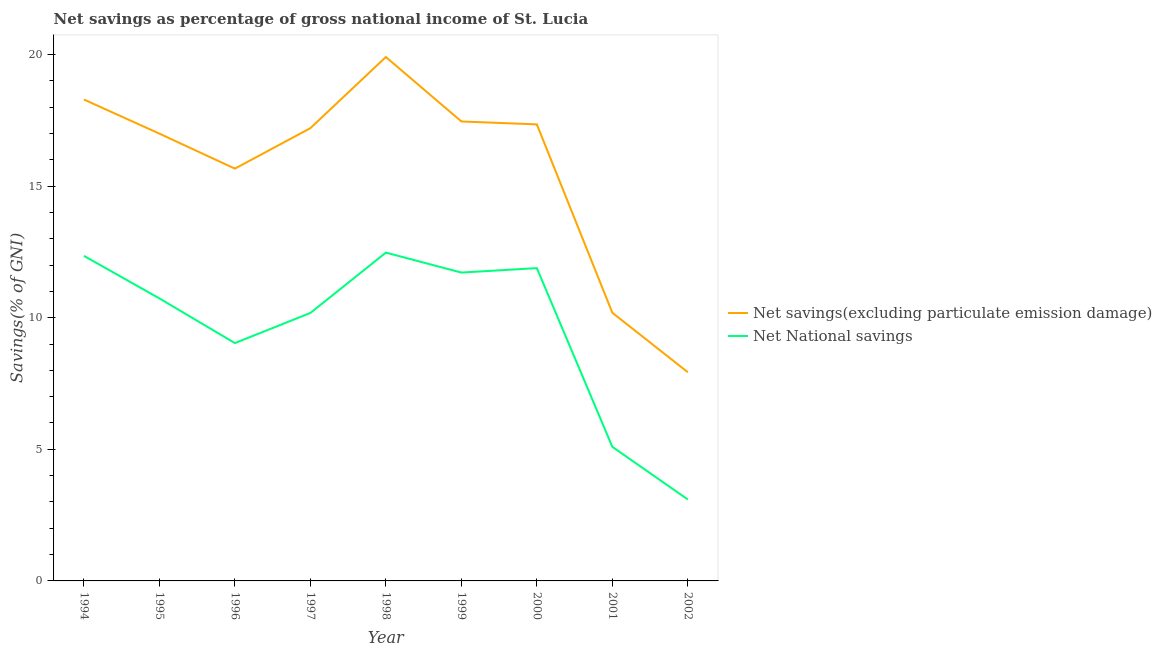Does the line corresponding to net savings(excluding particulate emission damage) intersect with the line corresponding to net national savings?
Your response must be concise. No. What is the net savings(excluding particulate emission damage) in 1994?
Give a very brief answer. 18.29. Across all years, what is the maximum net savings(excluding particulate emission damage)?
Offer a very short reply. 19.9. Across all years, what is the minimum net national savings?
Make the answer very short. 3.09. What is the total net savings(excluding particulate emission damage) in the graph?
Provide a succinct answer. 140.97. What is the difference between the net savings(excluding particulate emission damage) in 1997 and that in 2000?
Give a very brief answer. -0.14. What is the difference between the net savings(excluding particulate emission damage) in 1996 and the net national savings in 1994?
Your response must be concise. 3.31. What is the average net national savings per year?
Ensure brevity in your answer.  9.62. In the year 1997, what is the difference between the net savings(excluding particulate emission damage) and net national savings?
Give a very brief answer. 7.02. In how many years, is the net national savings greater than 19 %?
Give a very brief answer. 0. What is the ratio of the net savings(excluding particulate emission damage) in 1994 to that in 1995?
Offer a terse response. 1.08. What is the difference between the highest and the second highest net national savings?
Offer a terse response. 0.12. What is the difference between the highest and the lowest net savings(excluding particulate emission damage)?
Provide a short and direct response. 11.98. In how many years, is the net national savings greater than the average net national savings taken over all years?
Your answer should be compact. 6. Is the net national savings strictly greater than the net savings(excluding particulate emission damage) over the years?
Your answer should be compact. No. Is the net savings(excluding particulate emission damage) strictly less than the net national savings over the years?
Make the answer very short. No. How many lines are there?
Provide a succinct answer. 2. How many years are there in the graph?
Provide a succinct answer. 9. What is the difference between two consecutive major ticks on the Y-axis?
Offer a terse response. 5. Does the graph contain any zero values?
Your answer should be compact. No. Does the graph contain grids?
Keep it short and to the point. No. What is the title of the graph?
Give a very brief answer. Net savings as percentage of gross national income of St. Lucia. Does "Male" appear as one of the legend labels in the graph?
Keep it short and to the point. No. What is the label or title of the Y-axis?
Ensure brevity in your answer.  Savings(% of GNI). What is the Savings(% of GNI) of Net savings(excluding particulate emission damage) in 1994?
Your response must be concise. 18.29. What is the Savings(% of GNI) of Net National savings in 1994?
Your answer should be compact. 12.35. What is the Savings(% of GNI) of Net savings(excluding particulate emission damage) in 1995?
Keep it short and to the point. 16.99. What is the Savings(% of GNI) of Net National savings in 1995?
Provide a short and direct response. 10.73. What is the Savings(% of GNI) in Net savings(excluding particulate emission damage) in 1996?
Offer a terse response. 15.66. What is the Savings(% of GNI) of Net National savings in 1996?
Give a very brief answer. 9.04. What is the Savings(% of GNI) of Net savings(excluding particulate emission damage) in 1997?
Your response must be concise. 17.2. What is the Savings(% of GNI) in Net National savings in 1997?
Offer a terse response. 10.18. What is the Savings(% of GNI) of Net savings(excluding particulate emission damage) in 1998?
Make the answer very short. 19.9. What is the Savings(% of GNI) of Net National savings in 1998?
Keep it short and to the point. 12.47. What is the Savings(% of GNI) of Net savings(excluding particulate emission damage) in 1999?
Ensure brevity in your answer.  17.46. What is the Savings(% of GNI) in Net National savings in 1999?
Your answer should be very brief. 11.71. What is the Savings(% of GNI) of Net savings(excluding particulate emission damage) in 2000?
Keep it short and to the point. 17.34. What is the Savings(% of GNI) of Net National savings in 2000?
Your answer should be compact. 11.88. What is the Savings(% of GNI) of Net savings(excluding particulate emission damage) in 2001?
Make the answer very short. 10.19. What is the Savings(% of GNI) in Net National savings in 2001?
Your response must be concise. 5.09. What is the Savings(% of GNI) of Net savings(excluding particulate emission damage) in 2002?
Provide a succinct answer. 7.93. What is the Savings(% of GNI) in Net National savings in 2002?
Your answer should be very brief. 3.09. Across all years, what is the maximum Savings(% of GNI) in Net savings(excluding particulate emission damage)?
Your answer should be compact. 19.9. Across all years, what is the maximum Savings(% of GNI) of Net National savings?
Make the answer very short. 12.47. Across all years, what is the minimum Savings(% of GNI) in Net savings(excluding particulate emission damage)?
Keep it short and to the point. 7.93. Across all years, what is the minimum Savings(% of GNI) of Net National savings?
Your answer should be very brief. 3.09. What is the total Savings(% of GNI) in Net savings(excluding particulate emission damage) in the graph?
Give a very brief answer. 140.97. What is the total Savings(% of GNI) in Net National savings in the graph?
Make the answer very short. 86.56. What is the difference between the Savings(% of GNI) in Net savings(excluding particulate emission damage) in 1994 and that in 1995?
Give a very brief answer. 1.3. What is the difference between the Savings(% of GNI) of Net National savings in 1994 and that in 1995?
Your answer should be very brief. 1.62. What is the difference between the Savings(% of GNI) of Net savings(excluding particulate emission damage) in 1994 and that in 1996?
Offer a terse response. 2.63. What is the difference between the Savings(% of GNI) of Net National savings in 1994 and that in 1996?
Offer a terse response. 3.31. What is the difference between the Savings(% of GNI) of Net savings(excluding particulate emission damage) in 1994 and that in 1997?
Provide a short and direct response. 1.09. What is the difference between the Savings(% of GNI) of Net National savings in 1994 and that in 1997?
Give a very brief answer. 2.17. What is the difference between the Savings(% of GNI) in Net savings(excluding particulate emission damage) in 1994 and that in 1998?
Your answer should be compact. -1.62. What is the difference between the Savings(% of GNI) of Net National savings in 1994 and that in 1998?
Make the answer very short. -0.12. What is the difference between the Savings(% of GNI) of Net savings(excluding particulate emission damage) in 1994 and that in 1999?
Your response must be concise. 0.83. What is the difference between the Savings(% of GNI) of Net National savings in 1994 and that in 1999?
Keep it short and to the point. 0.63. What is the difference between the Savings(% of GNI) in Net savings(excluding particulate emission damage) in 1994 and that in 2000?
Your response must be concise. 0.94. What is the difference between the Savings(% of GNI) of Net National savings in 1994 and that in 2000?
Offer a terse response. 0.47. What is the difference between the Savings(% of GNI) of Net savings(excluding particulate emission damage) in 1994 and that in 2001?
Your answer should be compact. 8.1. What is the difference between the Savings(% of GNI) in Net National savings in 1994 and that in 2001?
Offer a terse response. 7.26. What is the difference between the Savings(% of GNI) in Net savings(excluding particulate emission damage) in 1994 and that in 2002?
Your answer should be very brief. 10.36. What is the difference between the Savings(% of GNI) of Net National savings in 1994 and that in 2002?
Offer a terse response. 9.26. What is the difference between the Savings(% of GNI) in Net savings(excluding particulate emission damage) in 1995 and that in 1996?
Keep it short and to the point. 1.33. What is the difference between the Savings(% of GNI) in Net National savings in 1995 and that in 1996?
Keep it short and to the point. 1.7. What is the difference between the Savings(% of GNI) of Net savings(excluding particulate emission damage) in 1995 and that in 1997?
Your answer should be compact. -0.21. What is the difference between the Savings(% of GNI) in Net National savings in 1995 and that in 1997?
Your answer should be compact. 0.55. What is the difference between the Savings(% of GNI) of Net savings(excluding particulate emission damage) in 1995 and that in 1998?
Give a very brief answer. -2.91. What is the difference between the Savings(% of GNI) of Net National savings in 1995 and that in 1998?
Keep it short and to the point. -1.74. What is the difference between the Savings(% of GNI) of Net savings(excluding particulate emission damage) in 1995 and that in 1999?
Make the answer very short. -0.46. What is the difference between the Savings(% of GNI) of Net National savings in 1995 and that in 1999?
Offer a very short reply. -0.98. What is the difference between the Savings(% of GNI) in Net savings(excluding particulate emission damage) in 1995 and that in 2000?
Offer a terse response. -0.35. What is the difference between the Savings(% of GNI) in Net National savings in 1995 and that in 2000?
Ensure brevity in your answer.  -1.15. What is the difference between the Savings(% of GNI) in Net savings(excluding particulate emission damage) in 1995 and that in 2001?
Your answer should be very brief. 6.8. What is the difference between the Savings(% of GNI) in Net National savings in 1995 and that in 2001?
Ensure brevity in your answer.  5.64. What is the difference between the Savings(% of GNI) in Net savings(excluding particulate emission damage) in 1995 and that in 2002?
Provide a succinct answer. 9.07. What is the difference between the Savings(% of GNI) of Net National savings in 1995 and that in 2002?
Give a very brief answer. 7.64. What is the difference between the Savings(% of GNI) in Net savings(excluding particulate emission damage) in 1996 and that in 1997?
Ensure brevity in your answer.  -1.54. What is the difference between the Savings(% of GNI) of Net National savings in 1996 and that in 1997?
Your answer should be compact. -1.14. What is the difference between the Savings(% of GNI) of Net savings(excluding particulate emission damage) in 1996 and that in 1998?
Make the answer very short. -4.24. What is the difference between the Savings(% of GNI) in Net National savings in 1996 and that in 1998?
Your answer should be very brief. -3.44. What is the difference between the Savings(% of GNI) of Net savings(excluding particulate emission damage) in 1996 and that in 1999?
Offer a terse response. -1.79. What is the difference between the Savings(% of GNI) of Net National savings in 1996 and that in 1999?
Provide a succinct answer. -2.68. What is the difference between the Savings(% of GNI) of Net savings(excluding particulate emission damage) in 1996 and that in 2000?
Offer a very short reply. -1.68. What is the difference between the Savings(% of GNI) of Net National savings in 1996 and that in 2000?
Offer a very short reply. -2.85. What is the difference between the Savings(% of GNI) in Net savings(excluding particulate emission damage) in 1996 and that in 2001?
Provide a short and direct response. 5.48. What is the difference between the Savings(% of GNI) of Net National savings in 1996 and that in 2001?
Make the answer very short. 3.94. What is the difference between the Savings(% of GNI) in Net savings(excluding particulate emission damage) in 1996 and that in 2002?
Make the answer very short. 7.74. What is the difference between the Savings(% of GNI) in Net National savings in 1996 and that in 2002?
Offer a terse response. 5.94. What is the difference between the Savings(% of GNI) of Net savings(excluding particulate emission damage) in 1997 and that in 1998?
Provide a short and direct response. -2.7. What is the difference between the Savings(% of GNI) of Net National savings in 1997 and that in 1998?
Provide a succinct answer. -2.29. What is the difference between the Savings(% of GNI) in Net savings(excluding particulate emission damage) in 1997 and that in 1999?
Make the answer very short. -0.25. What is the difference between the Savings(% of GNI) of Net National savings in 1997 and that in 1999?
Provide a succinct answer. -1.53. What is the difference between the Savings(% of GNI) of Net savings(excluding particulate emission damage) in 1997 and that in 2000?
Ensure brevity in your answer.  -0.14. What is the difference between the Savings(% of GNI) in Net National savings in 1997 and that in 2000?
Ensure brevity in your answer.  -1.7. What is the difference between the Savings(% of GNI) in Net savings(excluding particulate emission damage) in 1997 and that in 2001?
Give a very brief answer. 7.01. What is the difference between the Savings(% of GNI) in Net National savings in 1997 and that in 2001?
Offer a very short reply. 5.09. What is the difference between the Savings(% of GNI) of Net savings(excluding particulate emission damage) in 1997 and that in 2002?
Ensure brevity in your answer.  9.27. What is the difference between the Savings(% of GNI) of Net National savings in 1997 and that in 2002?
Provide a short and direct response. 7.09. What is the difference between the Savings(% of GNI) of Net savings(excluding particulate emission damage) in 1998 and that in 1999?
Ensure brevity in your answer.  2.45. What is the difference between the Savings(% of GNI) of Net National savings in 1998 and that in 1999?
Make the answer very short. 0.76. What is the difference between the Savings(% of GNI) in Net savings(excluding particulate emission damage) in 1998 and that in 2000?
Make the answer very short. 2.56. What is the difference between the Savings(% of GNI) of Net National savings in 1998 and that in 2000?
Your answer should be very brief. 0.59. What is the difference between the Savings(% of GNI) of Net savings(excluding particulate emission damage) in 1998 and that in 2001?
Ensure brevity in your answer.  9.72. What is the difference between the Savings(% of GNI) of Net National savings in 1998 and that in 2001?
Your response must be concise. 7.38. What is the difference between the Savings(% of GNI) in Net savings(excluding particulate emission damage) in 1998 and that in 2002?
Your answer should be very brief. 11.98. What is the difference between the Savings(% of GNI) of Net National savings in 1998 and that in 2002?
Your answer should be very brief. 9.38. What is the difference between the Savings(% of GNI) in Net savings(excluding particulate emission damage) in 1999 and that in 2000?
Your response must be concise. 0.11. What is the difference between the Savings(% of GNI) in Net National savings in 1999 and that in 2000?
Your answer should be compact. -0.17. What is the difference between the Savings(% of GNI) in Net savings(excluding particulate emission damage) in 1999 and that in 2001?
Your response must be concise. 7.27. What is the difference between the Savings(% of GNI) in Net National savings in 1999 and that in 2001?
Offer a very short reply. 6.62. What is the difference between the Savings(% of GNI) in Net savings(excluding particulate emission damage) in 1999 and that in 2002?
Offer a terse response. 9.53. What is the difference between the Savings(% of GNI) of Net National savings in 1999 and that in 2002?
Ensure brevity in your answer.  8.62. What is the difference between the Savings(% of GNI) in Net savings(excluding particulate emission damage) in 2000 and that in 2001?
Your answer should be compact. 7.16. What is the difference between the Savings(% of GNI) of Net National savings in 2000 and that in 2001?
Make the answer very short. 6.79. What is the difference between the Savings(% of GNI) in Net savings(excluding particulate emission damage) in 2000 and that in 2002?
Make the answer very short. 9.42. What is the difference between the Savings(% of GNI) in Net National savings in 2000 and that in 2002?
Keep it short and to the point. 8.79. What is the difference between the Savings(% of GNI) of Net savings(excluding particulate emission damage) in 2001 and that in 2002?
Your response must be concise. 2.26. What is the difference between the Savings(% of GNI) in Net National savings in 2001 and that in 2002?
Offer a terse response. 2. What is the difference between the Savings(% of GNI) in Net savings(excluding particulate emission damage) in 1994 and the Savings(% of GNI) in Net National savings in 1995?
Ensure brevity in your answer.  7.56. What is the difference between the Savings(% of GNI) of Net savings(excluding particulate emission damage) in 1994 and the Savings(% of GNI) of Net National savings in 1996?
Keep it short and to the point. 9.25. What is the difference between the Savings(% of GNI) in Net savings(excluding particulate emission damage) in 1994 and the Savings(% of GNI) in Net National savings in 1997?
Your answer should be compact. 8.11. What is the difference between the Savings(% of GNI) in Net savings(excluding particulate emission damage) in 1994 and the Savings(% of GNI) in Net National savings in 1998?
Your response must be concise. 5.82. What is the difference between the Savings(% of GNI) in Net savings(excluding particulate emission damage) in 1994 and the Savings(% of GNI) in Net National savings in 1999?
Your answer should be compact. 6.57. What is the difference between the Savings(% of GNI) of Net savings(excluding particulate emission damage) in 1994 and the Savings(% of GNI) of Net National savings in 2000?
Make the answer very short. 6.41. What is the difference between the Savings(% of GNI) of Net savings(excluding particulate emission damage) in 1994 and the Savings(% of GNI) of Net National savings in 2001?
Offer a terse response. 13.2. What is the difference between the Savings(% of GNI) of Net savings(excluding particulate emission damage) in 1994 and the Savings(% of GNI) of Net National savings in 2002?
Provide a short and direct response. 15.2. What is the difference between the Savings(% of GNI) of Net savings(excluding particulate emission damage) in 1995 and the Savings(% of GNI) of Net National savings in 1996?
Ensure brevity in your answer.  7.96. What is the difference between the Savings(% of GNI) of Net savings(excluding particulate emission damage) in 1995 and the Savings(% of GNI) of Net National savings in 1997?
Give a very brief answer. 6.81. What is the difference between the Savings(% of GNI) of Net savings(excluding particulate emission damage) in 1995 and the Savings(% of GNI) of Net National savings in 1998?
Offer a very short reply. 4.52. What is the difference between the Savings(% of GNI) in Net savings(excluding particulate emission damage) in 1995 and the Savings(% of GNI) in Net National savings in 1999?
Offer a very short reply. 5.28. What is the difference between the Savings(% of GNI) in Net savings(excluding particulate emission damage) in 1995 and the Savings(% of GNI) in Net National savings in 2000?
Your response must be concise. 5.11. What is the difference between the Savings(% of GNI) in Net savings(excluding particulate emission damage) in 1995 and the Savings(% of GNI) in Net National savings in 2001?
Make the answer very short. 11.9. What is the difference between the Savings(% of GNI) of Net savings(excluding particulate emission damage) in 1995 and the Savings(% of GNI) of Net National savings in 2002?
Offer a terse response. 13.9. What is the difference between the Savings(% of GNI) of Net savings(excluding particulate emission damage) in 1996 and the Savings(% of GNI) of Net National savings in 1997?
Keep it short and to the point. 5.48. What is the difference between the Savings(% of GNI) in Net savings(excluding particulate emission damage) in 1996 and the Savings(% of GNI) in Net National savings in 1998?
Offer a terse response. 3.19. What is the difference between the Savings(% of GNI) of Net savings(excluding particulate emission damage) in 1996 and the Savings(% of GNI) of Net National savings in 1999?
Give a very brief answer. 3.95. What is the difference between the Savings(% of GNI) of Net savings(excluding particulate emission damage) in 1996 and the Savings(% of GNI) of Net National savings in 2000?
Offer a very short reply. 3.78. What is the difference between the Savings(% of GNI) of Net savings(excluding particulate emission damage) in 1996 and the Savings(% of GNI) of Net National savings in 2001?
Provide a succinct answer. 10.57. What is the difference between the Savings(% of GNI) in Net savings(excluding particulate emission damage) in 1996 and the Savings(% of GNI) in Net National savings in 2002?
Offer a terse response. 12.57. What is the difference between the Savings(% of GNI) of Net savings(excluding particulate emission damage) in 1997 and the Savings(% of GNI) of Net National savings in 1998?
Offer a terse response. 4.73. What is the difference between the Savings(% of GNI) of Net savings(excluding particulate emission damage) in 1997 and the Savings(% of GNI) of Net National savings in 1999?
Give a very brief answer. 5.49. What is the difference between the Savings(% of GNI) in Net savings(excluding particulate emission damage) in 1997 and the Savings(% of GNI) in Net National savings in 2000?
Give a very brief answer. 5.32. What is the difference between the Savings(% of GNI) of Net savings(excluding particulate emission damage) in 1997 and the Savings(% of GNI) of Net National savings in 2001?
Offer a terse response. 12.11. What is the difference between the Savings(% of GNI) in Net savings(excluding particulate emission damage) in 1997 and the Savings(% of GNI) in Net National savings in 2002?
Provide a short and direct response. 14.11. What is the difference between the Savings(% of GNI) in Net savings(excluding particulate emission damage) in 1998 and the Savings(% of GNI) in Net National savings in 1999?
Make the answer very short. 8.19. What is the difference between the Savings(% of GNI) in Net savings(excluding particulate emission damage) in 1998 and the Savings(% of GNI) in Net National savings in 2000?
Your response must be concise. 8.02. What is the difference between the Savings(% of GNI) in Net savings(excluding particulate emission damage) in 1998 and the Savings(% of GNI) in Net National savings in 2001?
Keep it short and to the point. 14.81. What is the difference between the Savings(% of GNI) of Net savings(excluding particulate emission damage) in 1998 and the Savings(% of GNI) of Net National savings in 2002?
Provide a short and direct response. 16.81. What is the difference between the Savings(% of GNI) of Net savings(excluding particulate emission damage) in 1999 and the Savings(% of GNI) of Net National savings in 2000?
Your response must be concise. 5.57. What is the difference between the Savings(% of GNI) of Net savings(excluding particulate emission damage) in 1999 and the Savings(% of GNI) of Net National savings in 2001?
Make the answer very short. 12.36. What is the difference between the Savings(% of GNI) in Net savings(excluding particulate emission damage) in 1999 and the Savings(% of GNI) in Net National savings in 2002?
Your response must be concise. 14.36. What is the difference between the Savings(% of GNI) in Net savings(excluding particulate emission damage) in 2000 and the Savings(% of GNI) in Net National savings in 2001?
Offer a very short reply. 12.25. What is the difference between the Savings(% of GNI) in Net savings(excluding particulate emission damage) in 2000 and the Savings(% of GNI) in Net National savings in 2002?
Keep it short and to the point. 14.25. What is the difference between the Savings(% of GNI) in Net savings(excluding particulate emission damage) in 2001 and the Savings(% of GNI) in Net National savings in 2002?
Your answer should be compact. 7.09. What is the average Savings(% of GNI) of Net savings(excluding particulate emission damage) per year?
Give a very brief answer. 15.66. What is the average Savings(% of GNI) of Net National savings per year?
Your answer should be compact. 9.62. In the year 1994, what is the difference between the Savings(% of GNI) in Net savings(excluding particulate emission damage) and Savings(% of GNI) in Net National savings?
Give a very brief answer. 5.94. In the year 1995, what is the difference between the Savings(% of GNI) of Net savings(excluding particulate emission damage) and Savings(% of GNI) of Net National savings?
Your answer should be very brief. 6.26. In the year 1996, what is the difference between the Savings(% of GNI) of Net savings(excluding particulate emission damage) and Savings(% of GNI) of Net National savings?
Offer a very short reply. 6.63. In the year 1997, what is the difference between the Savings(% of GNI) of Net savings(excluding particulate emission damage) and Savings(% of GNI) of Net National savings?
Ensure brevity in your answer.  7.02. In the year 1998, what is the difference between the Savings(% of GNI) in Net savings(excluding particulate emission damage) and Savings(% of GNI) in Net National savings?
Your response must be concise. 7.43. In the year 1999, what is the difference between the Savings(% of GNI) of Net savings(excluding particulate emission damage) and Savings(% of GNI) of Net National savings?
Provide a succinct answer. 5.74. In the year 2000, what is the difference between the Savings(% of GNI) in Net savings(excluding particulate emission damage) and Savings(% of GNI) in Net National savings?
Provide a succinct answer. 5.46. In the year 2001, what is the difference between the Savings(% of GNI) in Net savings(excluding particulate emission damage) and Savings(% of GNI) in Net National savings?
Give a very brief answer. 5.09. In the year 2002, what is the difference between the Savings(% of GNI) of Net savings(excluding particulate emission damage) and Savings(% of GNI) of Net National savings?
Ensure brevity in your answer.  4.83. What is the ratio of the Savings(% of GNI) in Net savings(excluding particulate emission damage) in 1994 to that in 1995?
Ensure brevity in your answer.  1.08. What is the ratio of the Savings(% of GNI) in Net National savings in 1994 to that in 1995?
Your response must be concise. 1.15. What is the ratio of the Savings(% of GNI) in Net savings(excluding particulate emission damage) in 1994 to that in 1996?
Offer a very short reply. 1.17. What is the ratio of the Savings(% of GNI) in Net National savings in 1994 to that in 1996?
Make the answer very short. 1.37. What is the ratio of the Savings(% of GNI) of Net savings(excluding particulate emission damage) in 1994 to that in 1997?
Make the answer very short. 1.06. What is the ratio of the Savings(% of GNI) in Net National savings in 1994 to that in 1997?
Your response must be concise. 1.21. What is the ratio of the Savings(% of GNI) of Net savings(excluding particulate emission damage) in 1994 to that in 1998?
Give a very brief answer. 0.92. What is the ratio of the Savings(% of GNI) in Net National savings in 1994 to that in 1998?
Your answer should be very brief. 0.99. What is the ratio of the Savings(% of GNI) in Net savings(excluding particulate emission damage) in 1994 to that in 1999?
Your answer should be compact. 1.05. What is the ratio of the Savings(% of GNI) in Net National savings in 1994 to that in 1999?
Give a very brief answer. 1.05. What is the ratio of the Savings(% of GNI) in Net savings(excluding particulate emission damage) in 1994 to that in 2000?
Offer a very short reply. 1.05. What is the ratio of the Savings(% of GNI) of Net National savings in 1994 to that in 2000?
Ensure brevity in your answer.  1.04. What is the ratio of the Savings(% of GNI) of Net savings(excluding particulate emission damage) in 1994 to that in 2001?
Make the answer very short. 1.8. What is the ratio of the Savings(% of GNI) in Net National savings in 1994 to that in 2001?
Offer a terse response. 2.42. What is the ratio of the Savings(% of GNI) of Net savings(excluding particulate emission damage) in 1994 to that in 2002?
Provide a short and direct response. 2.31. What is the ratio of the Savings(% of GNI) of Net National savings in 1994 to that in 2002?
Provide a succinct answer. 3.99. What is the ratio of the Savings(% of GNI) of Net savings(excluding particulate emission damage) in 1995 to that in 1996?
Offer a terse response. 1.08. What is the ratio of the Savings(% of GNI) of Net National savings in 1995 to that in 1996?
Make the answer very short. 1.19. What is the ratio of the Savings(% of GNI) in Net savings(excluding particulate emission damage) in 1995 to that in 1997?
Your response must be concise. 0.99. What is the ratio of the Savings(% of GNI) of Net National savings in 1995 to that in 1997?
Ensure brevity in your answer.  1.05. What is the ratio of the Savings(% of GNI) of Net savings(excluding particulate emission damage) in 1995 to that in 1998?
Give a very brief answer. 0.85. What is the ratio of the Savings(% of GNI) in Net National savings in 1995 to that in 1998?
Offer a very short reply. 0.86. What is the ratio of the Savings(% of GNI) in Net savings(excluding particulate emission damage) in 1995 to that in 1999?
Offer a terse response. 0.97. What is the ratio of the Savings(% of GNI) in Net National savings in 1995 to that in 1999?
Provide a short and direct response. 0.92. What is the ratio of the Savings(% of GNI) of Net savings(excluding particulate emission damage) in 1995 to that in 2000?
Provide a succinct answer. 0.98. What is the ratio of the Savings(% of GNI) in Net National savings in 1995 to that in 2000?
Offer a very short reply. 0.9. What is the ratio of the Savings(% of GNI) in Net savings(excluding particulate emission damage) in 1995 to that in 2001?
Offer a very short reply. 1.67. What is the ratio of the Savings(% of GNI) in Net National savings in 1995 to that in 2001?
Offer a very short reply. 2.11. What is the ratio of the Savings(% of GNI) of Net savings(excluding particulate emission damage) in 1995 to that in 2002?
Your response must be concise. 2.14. What is the ratio of the Savings(% of GNI) of Net National savings in 1995 to that in 2002?
Offer a very short reply. 3.47. What is the ratio of the Savings(% of GNI) of Net savings(excluding particulate emission damage) in 1996 to that in 1997?
Make the answer very short. 0.91. What is the ratio of the Savings(% of GNI) in Net National savings in 1996 to that in 1997?
Your response must be concise. 0.89. What is the ratio of the Savings(% of GNI) in Net savings(excluding particulate emission damage) in 1996 to that in 1998?
Keep it short and to the point. 0.79. What is the ratio of the Savings(% of GNI) of Net National savings in 1996 to that in 1998?
Give a very brief answer. 0.72. What is the ratio of the Savings(% of GNI) in Net savings(excluding particulate emission damage) in 1996 to that in 1999?
Your answer should be very brief. 0.9. What is the ratio of the Savings(% of GNI) in Net National savings in 1996 to that in 1999?
Provide a short and direct response. 0.77. What is the ratio of the Savings(% of GNI) of Net savings(excluding particulate emission damage) in 1996 to that in 2000?
Ensure brevity in your answer.  0.9. What is the ratio of the Savings(% of GNI) in Net National savings in 1996 to that in 2000?
Give a very brief answer. 0.76. What is the ratio of the Savings(% of GNI) of Net savings(excluding particulate emission damage) in 1996 to that in 2001?
Offer a very short reply. 1.54. What is the ratio of the Savings(% of GNI) of Net National savings in 1996 to that in 2001?
Provide a short and direct response. 1.77. What is the ratio of the Savings(% of GNI) in Net savings(excluding particulate emission damage) in 1996 to that in 2002?
Your response must be concise. 1.98. What is the ratio of the Savings(% of GNI) in Net National savings in 1996 to that in 2002?
Ensure brevity in your answer.  2.92. What is the ratio of the Savings(% of GNI) of Net savings(excluding particulate emission damage) in 1997 to that in 1998?
Make the answer very short. 0.86. What is the ratio of the Savings(% of GNI) in Net National savings in 1997 to that in 1998?
Keep it short and to the point. 0.82. What is the ratio of the Savings(% of GNI) in Net savings(excluding particulate emission damage) in 1997 to that in 1999?
Make the answer very short. 0.99. What is the ratio of the Savings(% of GNI) in Net National savings in 1997 to that in 1999?
Provide a short and direct response. 0.87. What is the ratio of the Savings(% of GNI) in Net savings(excluding particulate emission damage) in 1997 to that in 2000?
Provide a short and direct response. 0.99. What is the ratio of the Savings(% of GNI) of Net National savings in 1997 to that in 2000?
Your answer should be very brief. 0.86. What is the ratio of the Savings(% of GNI) in Net savings(excluding particulate emission damage) in 1997 to that in 2001?
Keep it short and to the point. 1.69. What is the ratio of the Savings(% of GNI) of Net National savings in 1997 to that in 2001?
Provide a succinct answer. 2. What is the ratio of the Savings(% of GNI) of Net savings(excluding particulate emission damage) in 1997 to that in 2002?
Keep it short and to the point. 2.17. What is the ratio of the Savings(% of GNI) of Net National savings in 1997 to that in 2002?
Your response must be concise. 3.29. What is the ratio of the Savings(% of GNI) in Net savings(excluding particulate emission damage) in 1998 to that in 1999?
Provide a short and direct response. 1.14. What is the ratio of the Savings(% of GNI) of Net National savings in 1998 to that in 1999?
Ensure brevity in your answer.  1.06. What is the ratio of the Savings(% of GNI) in Net savings(excluding particulate emission damage) in 1998 to that in 2000?
Your response must be concise. 1.15. What is the ratio of the Savings(% of GNI) in Net National savings in 1998 to that in 2000?
Ensure brevity in your answer.  1.05. What is the ratio of the Savings(% of GNI) of Net savings(excluding particulate emission damage) in 1998 to that in 2001?
Offer a terse response. 1.95. What is the ratio of the Savings(% of GNI) of Net National savings in 1998 to that in 2001?
Make the answer very short. 2.45. What is the ratio of the Savings(% of GNI) in Net savings(excluding particulate emission damage) in 1998 to that in 2002?
Ensure brevity in your answer.  2.51. What is the ratio of the Savings(% of GNI) of Net National savings in 1998 to that in 2002?
Make the answer very short. 4.03. What is the ratio of the Savings(% of GNI) of Net savings(excluding particulate emission damage) in 1999 to that in 2000?
Give a very brief answer. 1.01. What is the ratio of the Savings(% of GNI) of Net National savings in 1999 to that in 2000?
Your answer should be compact. 0.99. What is the ratio of the Savings(% of GNI) in Net savings(excluding particulate emission damage) in 1999 to that in 2001?
Offer a terse response. 1.71. What is the ratio of the Savings(% of GNI) of Net National savings in 1999 to that in 2001?
Your response must be concise. 2.3. What is the ratio of the Savings(% of GNI) of Net savings(excluding particulate emission damage) in 1999 to that in 2002?
Your answer should be compact. 2.2. What is the ratio of the Savings(% of GNI) of Net National savings in 1999 to that in 2002?
Make the answer very short. 3.79. What is the ratio of the Savings(% of GNI) of Net savings(excluding particulate emission damage) in 2000 to that in 2001?
Offer a terse response. 1.7. What is the ratio of the Savings(% of GNI) of Net National savings in 2000 to that in 2001?
Ensure brevity in your answer.  2.33. What is the ratio of the Savings(% of GNI) in Net savings(excluding particulate emission damage) in 2000 to that in 2002?
Make the answer very short. 2.19. What is the ratio of the Savings(% of GNI) of Net National savings in 2000 to that in 2002?
Keep it short and to the point. 3.84. What is the ratio of the Savings(% of GNI) of Net savings(excluding particulate emission damage) in 2001 to that in 2002?
Offer a terse response. 1.29. What is the ratio of the Savings(% of GNI) of Net National savings in 2001 to that in 2002?
Give a very brief answer. 1.65. What is the difference between the highest and the second highest Savings(% of GNI) of Net savings(excluding particulate emission damage)?
Make the answer very short. 1.62. What is the difference between the highest and the second highest Savings(% of GNI) in Net National savings?
Make the answer very short. 0.12. What is the difference between the highest and the lowest Savings(% of GNI) of Net savings(excluding particulate emission damage)?
Your answer should be compact. 11.98. What is the difference between the highest and the lowest Savings(% of GNI) of Net National savings?
Offer a very short reply. 9.38. 